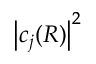<formula> <loc_0><loc_0><loc_500><loc_500>\left | c _ { j } ( R ) \right | ^ { 2 }</formula> 